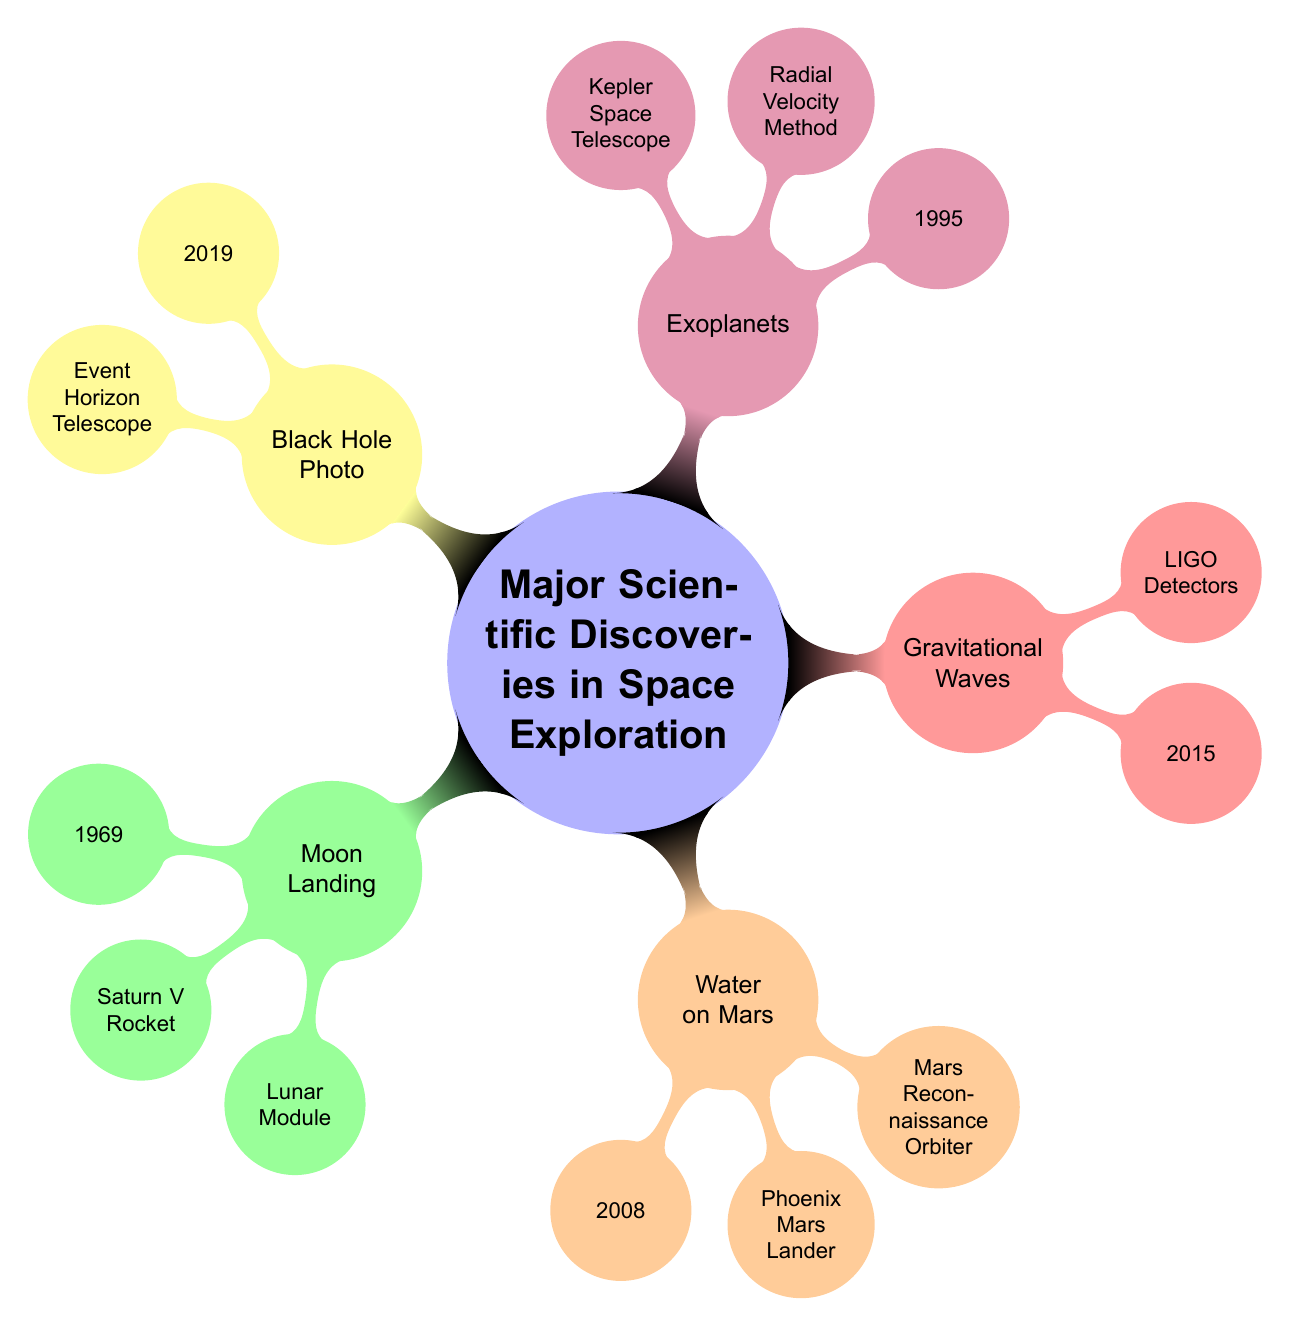What year did the Moon Landing occur? The diagram indicates that the Moon Landing took place in 1969. This information is represented in the node connected to the Moon Landing concept.
Answer: 1969 Who were the contributing scientists for the discovery of Exoplanets? According to the diagram, Michel Mayor and Didier Queloz were the contributing scientists for the discovery of Exoplanets, as listed under the Exoplanets node.
Answer: Michel Mayor, Didier Queloz What technology was used for detecting Gravitational Waves? The diagram specifies that LIGO Detectors were used in the detection of Gravitational Waves, as shown next to the corresponding node.
Answer: LIGO Detectors What does the discovery of Water on Mars imply for future missions? The implications highlighted in the diagram suggest that the discovery of Water on Mars "Increased potential for finding past or present life forms," detailing the significance for future explorations.
Answer: Increased potential for finding past or present life forms How many discoveries are listed in the mind map? By counting each major discovery listed as a child node under the main topic, the total number of discoveries is five: Moon Landing, Water on Mars, Gravitational Waves, Exoplanets, and Black Hole Photo.
Answer: 5 What technology was used in the first photograph of a Black Hole? The diagram states that the Event Horizon Telescope Array was the technology used to capture the first photograph of a Black Hole. This can be found under the Black Hole Photo node.
Answer: Event Horizon Telescope Array What relationship exists between the Moon Landing and future manned missions? The diagram indicates that the Moon Landing "Paved the way for future manned missions to other planets." This shows a direct implication of the Moon Landing discovery in relation to upcoming space explorations.
Answer: Paved the way for future manned missions to other planets Which discovery utilized the Phoenix Mars Lander? Referring to the diagram, the Phoenix Mars Lander was used in the discovery of Water on Mars, as noted within that node.
Answer: Water on Mars 